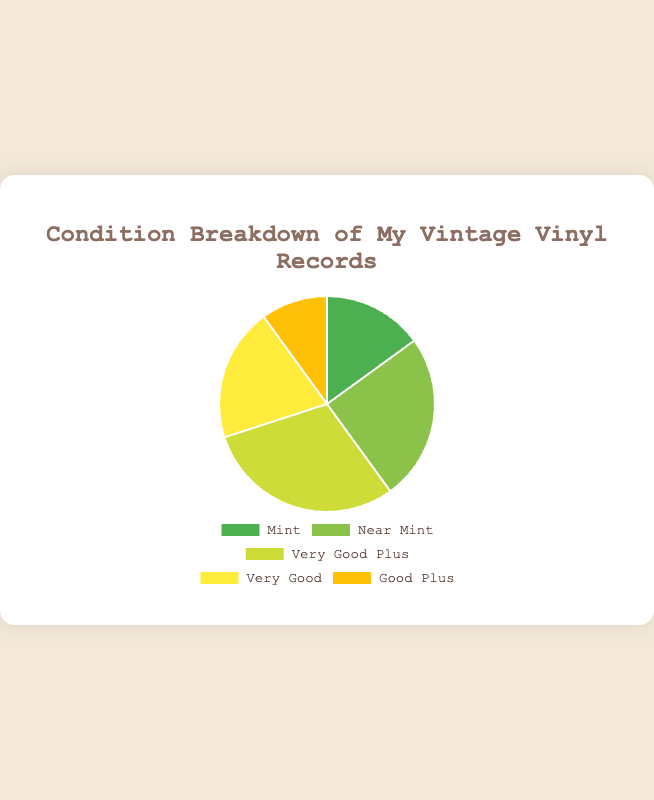What percentage of my vinyl records are in Mint condition? The Mint section makes up 15% of the pie chart.
Answer: 15% Which two conditions combined represent the highest percentage of my collection? Near Mint (25%) and Very Good Plus (30%) together make up 55%, the highest combined percentage.
Answer: Near Mint and Very Good Plus How many total percentage points do the Very Good and Good Plus conditions represent? Adding the percentages: Very Good (20%) + Good Plus (10%) results in 30%.
Answer: 30% Which condition is the least represented in my collection? Good Plus has the smallest section, representing 10% of the collection.
Answer: Good Plus What is the difference in percentage between Very Good Plus and Near Mint records? Very Good Plus is 30% and Near Mint is 25%. The difference is 30% - 25% = 5%.
Answer: 5% If I add the percentages of Mint and Near Mint conditions, what total do I get? Sum of Mint (15%) and Near Mint (25%) is 15% + 25% = 40%.
Answer: 40% How does the Mint condition compare to the Very Good condition in percentage terms? Mint is 15% and Very Good is 20%. Very Good exceeds Mint by 5%.
Answer: Very Good exceeds by 5% Which condition section in the pie chart is colored green? Near Mint is colored green.
Answer: Near Mint Among the given conditions, which two have almost an equal share of my vinyl records? Very Good (20%) and Mint (15%) are closest with a 5% difference.
Answer: Very Good and Mint What fraction of the pie chart does the Very Good Plus section cover? Very Good Plus makes up 30% of the pie chart.
Answer: 30% 